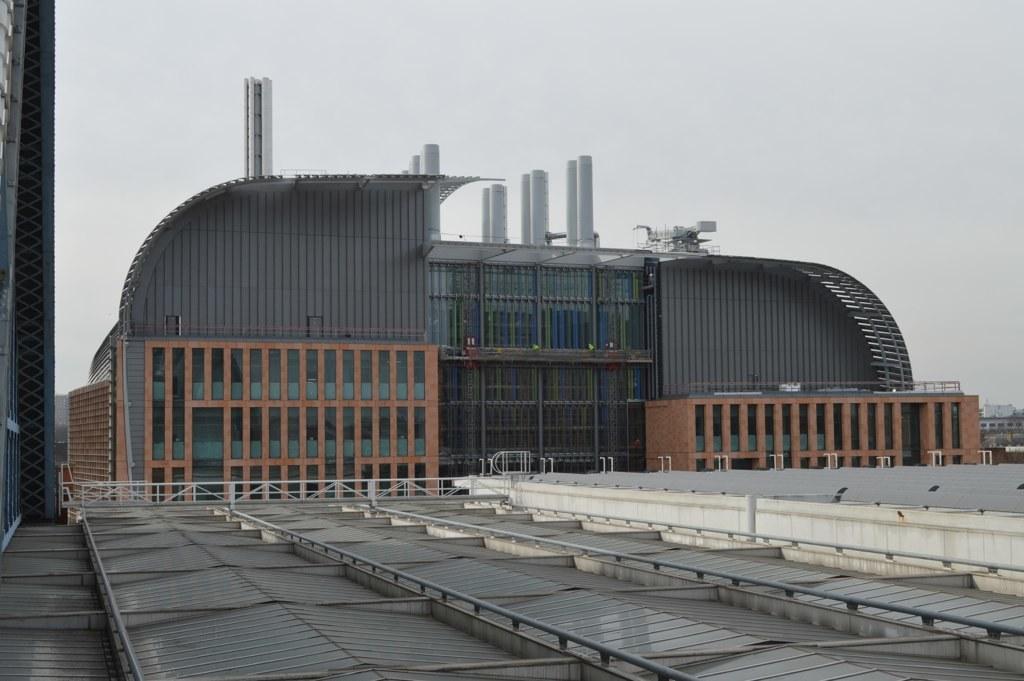How would you summarize this image in a sentence or two? In this picture we can see the railings and buildings. We can see the sky on top of the picture. 